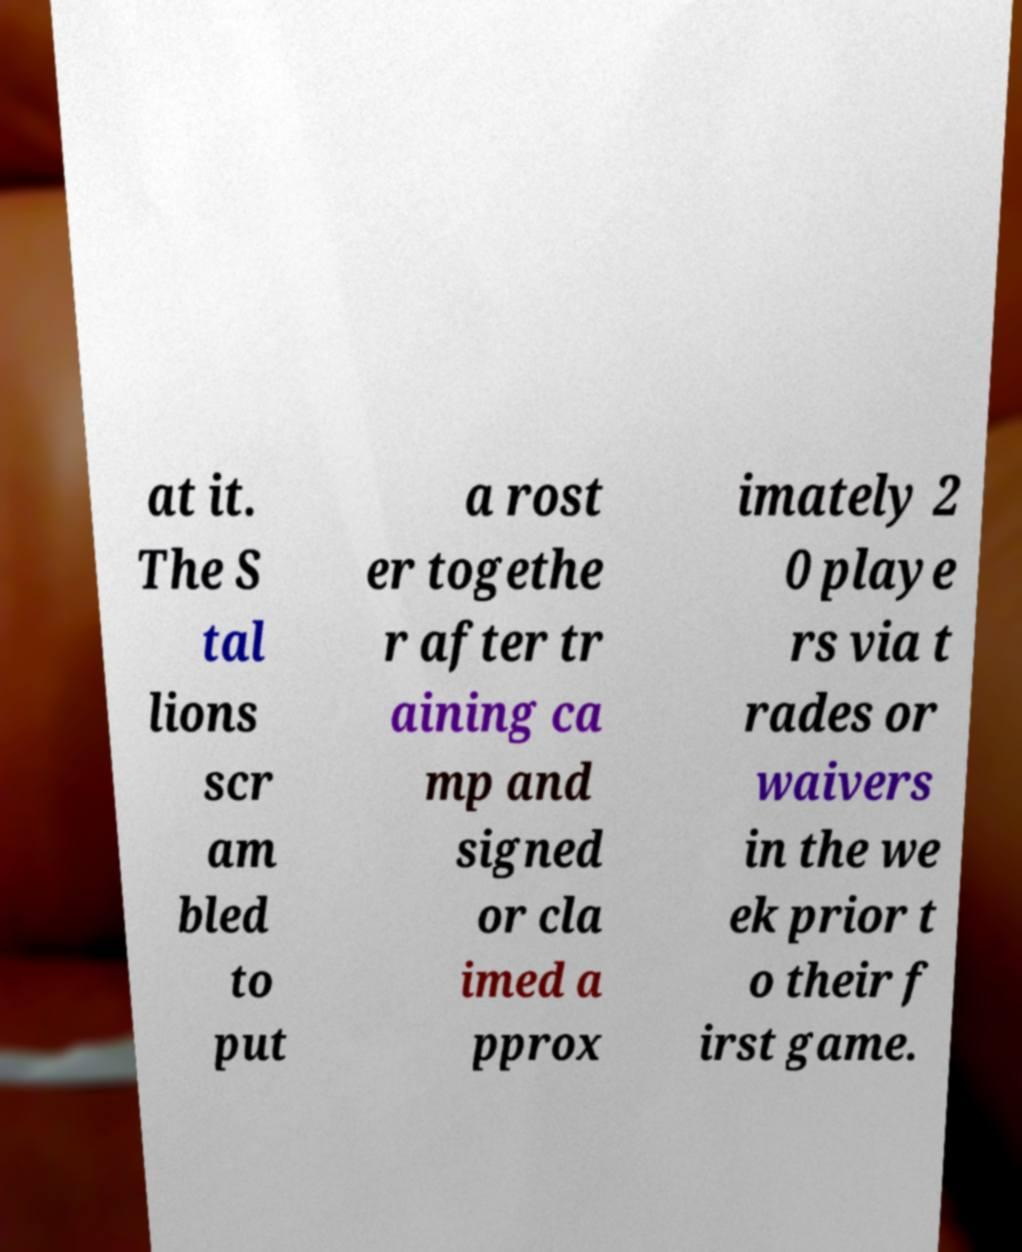For documentation purposes, I need the text within this image transcribed. Could you provide that? at it. The S tal lions scr am bled to put a rost er togethe r after tr aining ca mp and signed or cla imed a pprox imately 2 0 playe rs via t rades or waivers in the we ek prior t o their f irst game. 